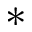Convert formula to latex. <formula><loc_0><loc_0><loc_500><loc_500>\ast</formula> 